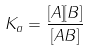<formula> <loc_0><loc_0><loc_500><loc_500>K _ { a } = \frac { [ A ] [ B ] } { [ A B ] }</formula> 